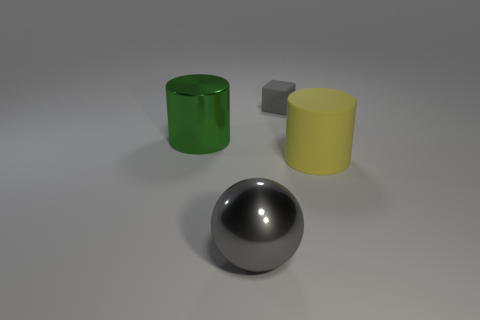Subtract 1 cylinders. How many cylinders are left? 1 Subtract all blocks. How many objects are left? 3 Add 3 big green shiny objects. How many objects exist? 7 Subtract all yellow cylinders. How many cylinders are left? 1 Subtract 0 purple cylinders. How many objects are left? 4 Subtract all brown cylinders. Subtract all blue balls. How many cylinders are left? 2 Subtract all brown cylinders. How many yellow cubes are left? 0 Subtract all large blue shiny cubes. Subtract all yellow objects. How many objects are left? 3 Add 2 big green cylinders. How many big green cylinders are left? 3 Add 1 cylinders. How many cylinders exist? 3 